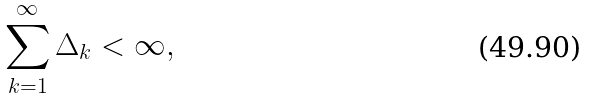<formula> <loc_0><loc_0><loc_500><loc_500>\sum _ { k = 1 } ^ { \infty } \Delta _ { k } < \infty ,</formula> 